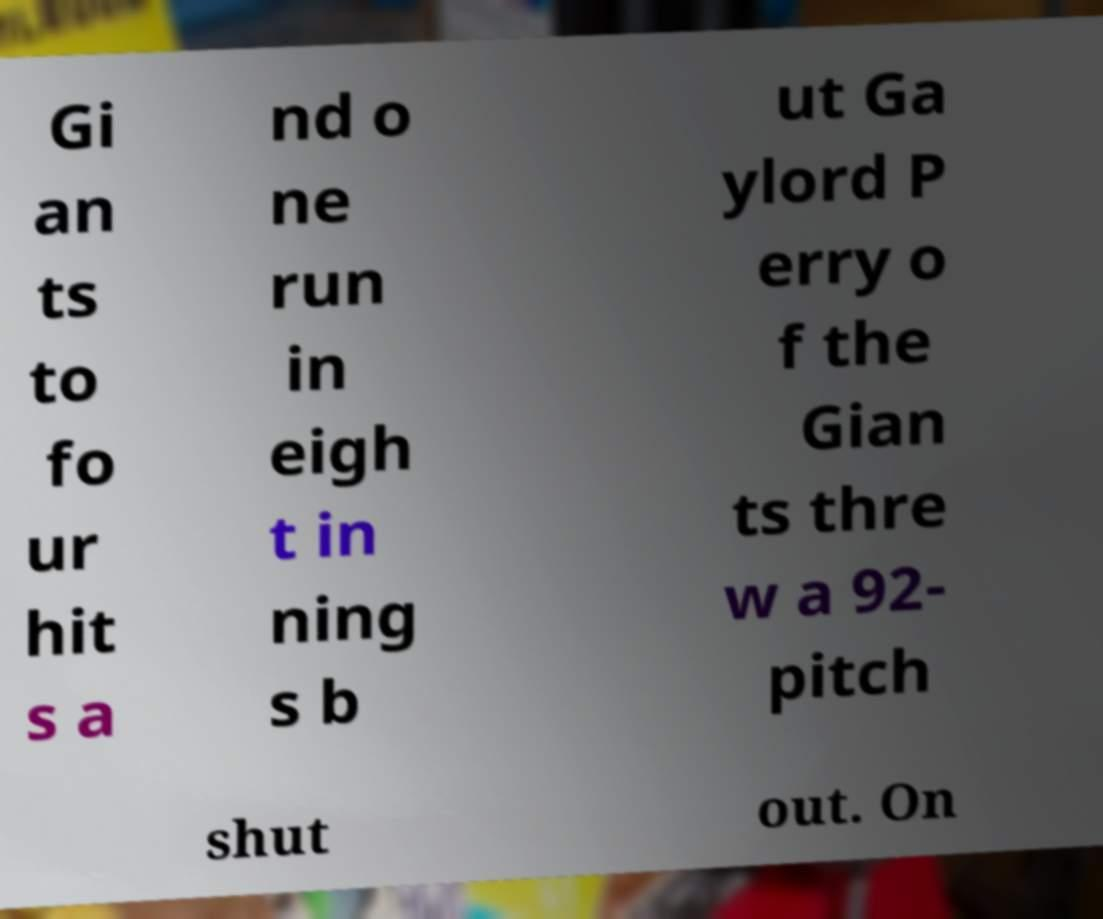There's text embedded in this image that I need extracted. Can you transcribe it verbatim? Gi an ts to fo ur hit s a nd o ne run in eigh t in ning s b ut Ga ylord P erry o f the Gian ts thre w a 92- pitch shut out. On 